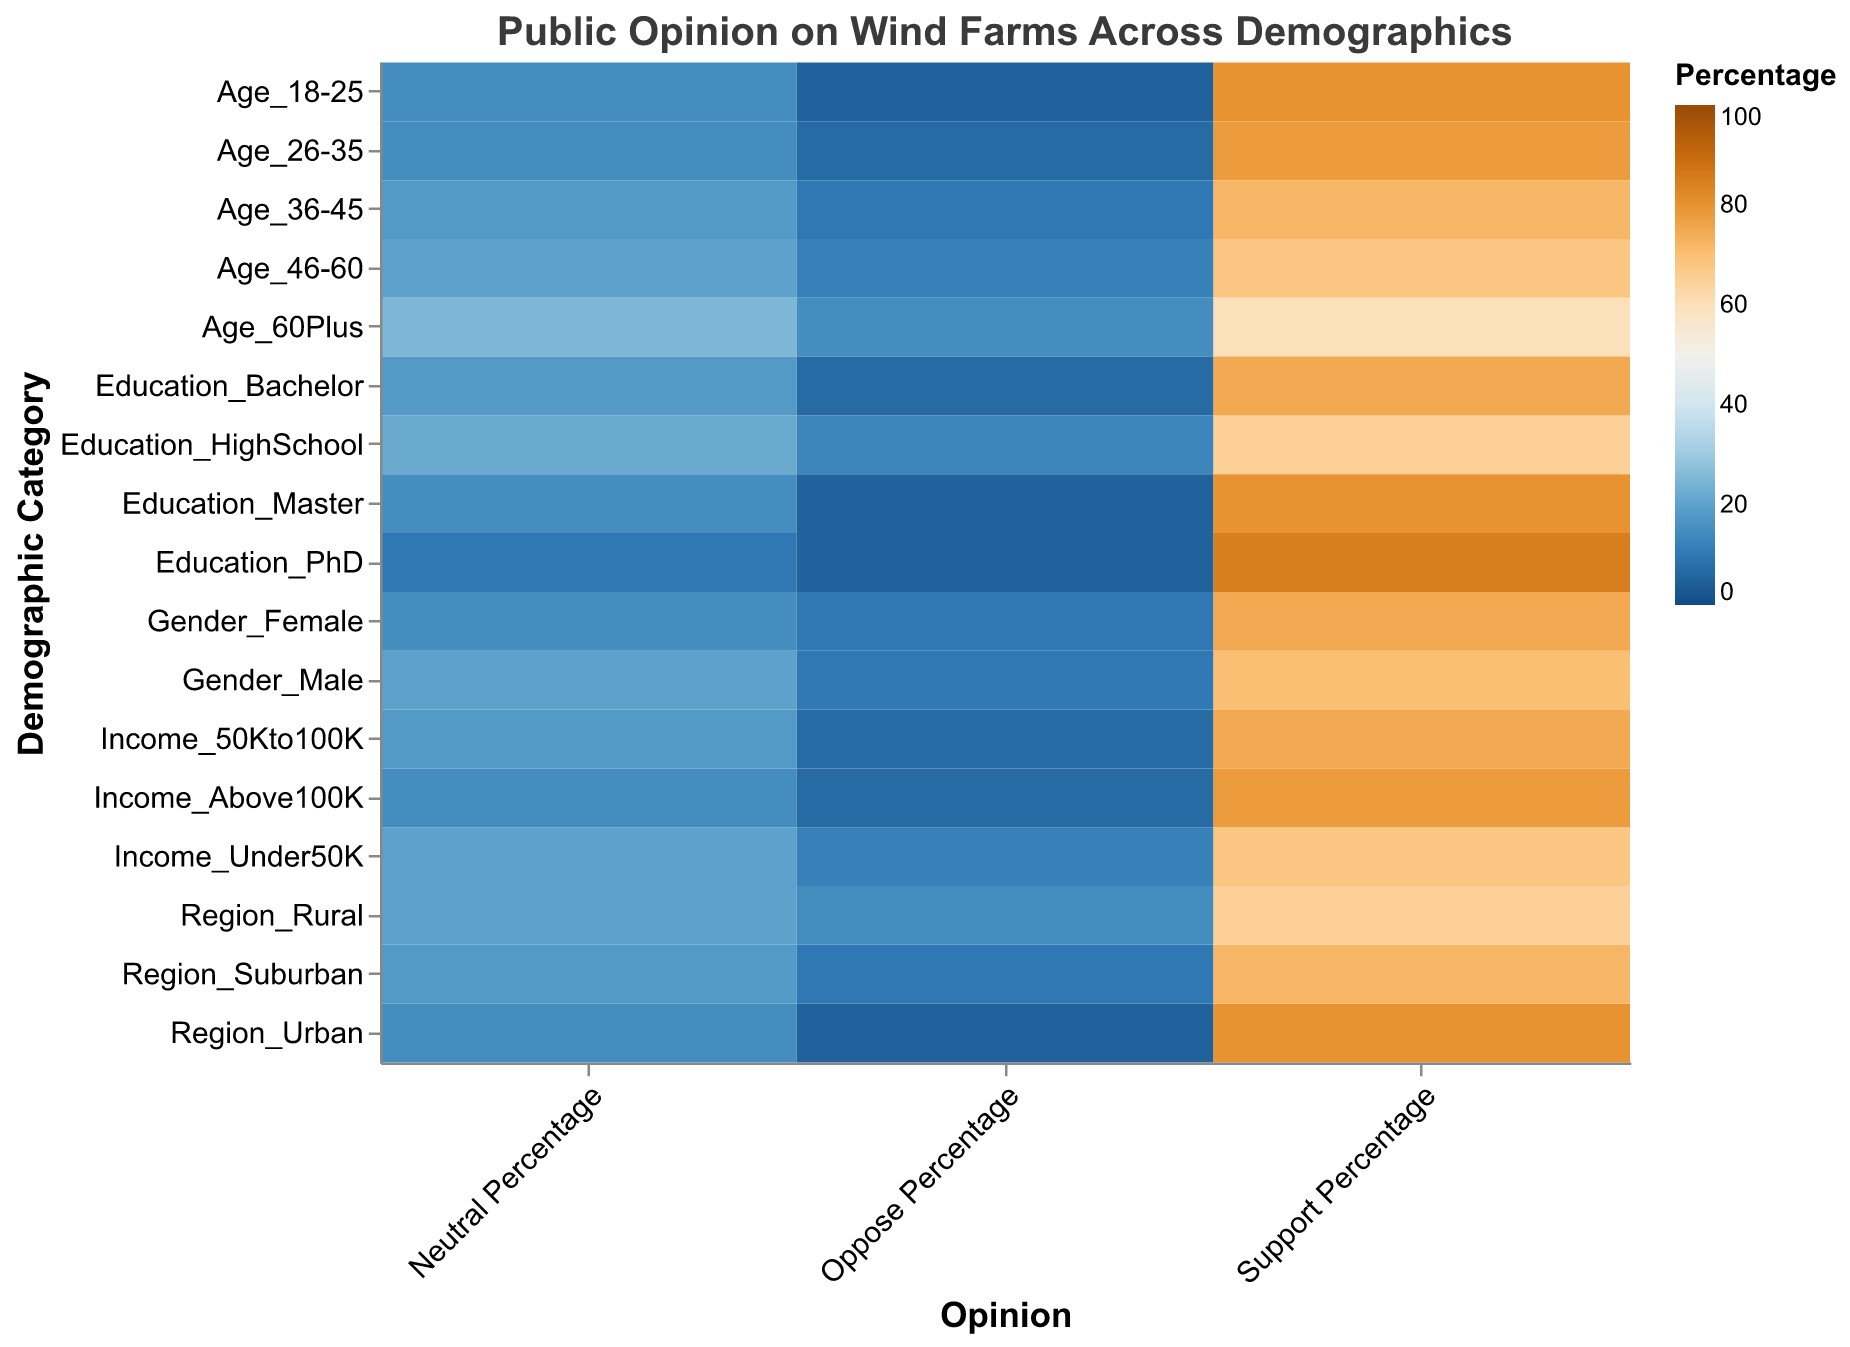What demographic has the highest support percentage for wind farms? The PhD-educated demographic shows the highest support, with a 85% support percentage. This information can be found in the cell of the heatmap corresponding to the 'Education_PhD' in the 'Support Percentage' column.
Answer: Education_PhD Which age group shows the least opposition to wind farms? The age group 18-25 shows the least opposition, with a 5% oppose percentage. This information can be found in the cell corresponding to 'Age_18-25' in the 'Oppose Percentage' column.
Answer: Age_18-25 How does the support for wind farms differ between urban and rural regions? Comparing the 'Support Percentage' column for 'Region_Urban' and 'Region_Rural', the urban region shows 80% support, while the rural region shows 65% support, indicating a difference of 15%.
Answer: 15% Which two demographics have almost the same support percentage, with a difference of less than 5%? Examining the 'Support Percentage' column, 'Age_26-35' and 'Income_Above100K' both have support percentages close to each other, 78% and 78% respectively, with a difference of 0%.
Answer: Age_26-35 and Income_Above100K What is the average support percentage for wind farms across all education levels? The support percentages for education levels (High School, Bachelor, Master, PhD) are 65%, 75%, 80%, and 85% respectively. Summing these gives 305%, and dividing by 4 levels gives an average of 76.25%.
Answer: 76.25% Which demographic shows the highest neutral percentage for wind farms? The demographic 'Age_60Plus' has the highest neutral percentage, with 25%. This can be observed by finding the highest value in the 'Neutral Percentage' column.
Answer: Age_60Plus What is the combined opposition percentage for 'Income_Under50K' and 'Income_50Kto100K'? The 'Oppose Percentage' for 'Income_Under50K' is 12% and for 'Income_50Kto100K' is 7%. Adding these, the combined opposition percentage is 19%.
Answer: 19% Which gender has a stronger support percentage for wind farms? The 'Support Percentage' for 'Gender_Female' is 75% and for 'Gender_Male' is 70%, indicating females have a stronger support.
Answer: Gender_Female By how much does the support percentage decrease from 'Age_18-25' to 'Age_60Plus'? The 'Support Percentage' for 'Age_18-25' is 80% and for 'Age_60Plus' is 60%, indicating a decrease of 20%.
Answer: 20% 